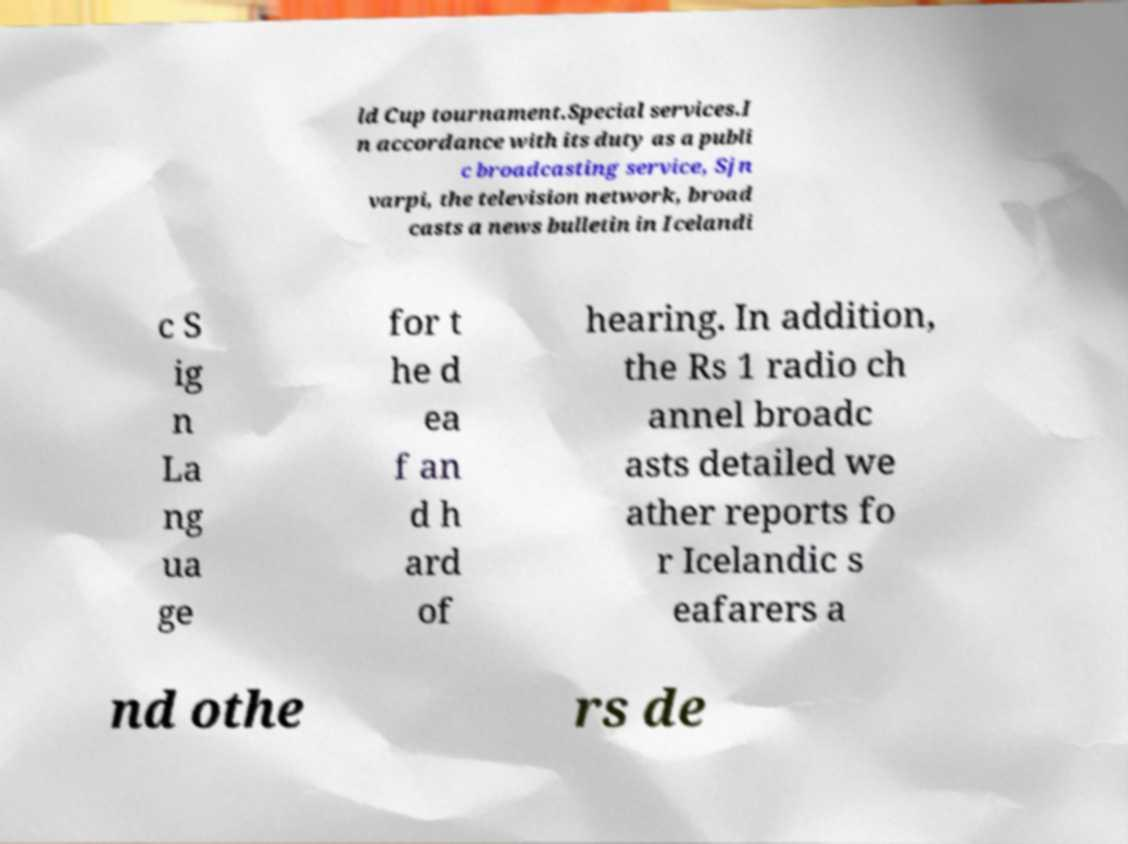Could you extract and type out the text from this image? ld Cup tournament.Special services.I n accordance with its duty as a publi c broadcasting service, Sjn varpi, the television network, broad casts a news bulletin in Icelandi c S ig n La ng ua ge for t he d ea f an d h ard of hearing. In addition, the Rs 1 radio ch annel broadc asts detailed we ather reports fo r Icelandic s eafarers a nd othe rs de 